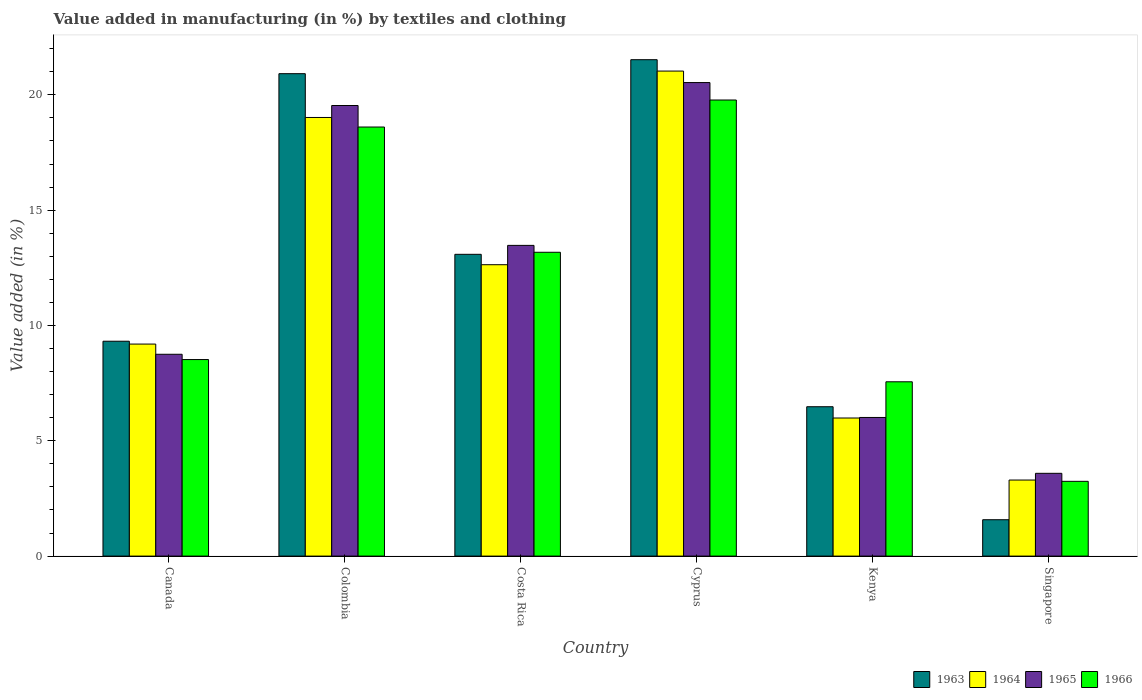How many different coloured bars are there?
Your answer should be compact. 4. Are the number of bars per tick equal to the number of legend labels?
Your response must be concise. Yes. How many bars are there on the 4th tick from the left?
Your response must be concise. 4. How many bars are there on the 4th tick from the right?
Your response must be concise. 4. What is the label of the 2nd group of bars from the left?
Provide a short and direct response. Colombia. In how many cases, is the number of bars for a given country not equal to the number of legend labels?
Your answer should be compact. 0. What is the percentage of value added in manufacturing by textiles and clothing in 1966 in Singapore?
Give a very brief answer. 3.24. Across all countries, what is the maximum percentage of value added in manufacturing by textiles and clothing in 1964?
Provide a short and direct response. 21.03. Across all countries, what is the minimum percentage of value added in manufacturing by textiles and clothing in 1965?
Offer a terse response. 3.59. In which country was the percentage of value added in manufacturing by textiles and clothing in 1963 maximum?
Provide a short and direct response. Cyprus. In which country was the percentage of value added in manufacturing by textiles and clothing in 1965 minimum?
Keep it short and to the point. Singapore. What is the total percentage of value added in manufacturing by textiles and clothing in 1964 in the graph?
Your answer should be very brief. 71.16. What is the difference between the percentage of value added in manufacturing by textiles and clothing in 1963 in Canada and that in Singapore?
Your answer should be compact. 7.74. What is the difference between the percentage of value added in manufacturing by textiles and clothing in 1965 in Costa Rica and the percentage of value added in manufacturing by textiles and clothing in 1964 in Kenya?
Make the answer very short. 7.48. What is the average percentage of value added in manufacturing by textiles and clothing in 1964 per country?
Make the answer very short. 11.86. What is the difference between the percentage of value added in manufacturing by textiles and clothing of/in 1964 and percentage of value added in manufacturing by textiles and clothing of/in 1963 in Canada?
Provide a short and direct response. -0.12. In how many countries, is the percentage of value added in manufacturing by textiles and clothing in 1964 greater than 18 %?
Offer a very short reply. 2. What is the ratio of the percentage of value added in manufacturing by textiles and clothing in 1963 in Canada to that in Singapore?
Make the answer very short. 5.91. What is the difference between the highest and the second highest percentage of value added in manufacturing by textiles and clothing in 1964?
Offer a very short reply. 6.38. What is the difference between the highest and the lowest percentage of value added in manufacturing by textiles and clothing in 1965?
Provide a succinct answer. 16.94. Is the sum of the percentage of value added in manufacturing by textiles and clothing in 1966 in Colombia and Singapore greater than the maximum percentage of value added in manufacturing by textiles and clothing in 1965 across all countries?
Keep it short and to the point. Yes. What does the 1st bar from the right in Colombia represents?
Your response must be concise. 1966. How many bars are there?
Provide a short and direct response. 24. Are all the bars in the graph horizontal?
Ensure brevity in your answer.  No. How many countries are there in the graph?
Make the answer very short. 6. Does the graph contain grids?
Make the answer very short. No. How many legend labels are there?
Your answer should be compact. 4. What is the title of the graph?
Provide a succinct answer. Value added in manufacturing (in %) by textiles and clothing. Does "2010" appear as one of the legend labels in the graph?
Provide a succinct answer. No. What is the label or title of the Y-axis?
Your response must be concise. Value added (in %). What is the Value added (in %) in 1963 in Canada?
Your answer should be compact. 9.32. What is the Value added (in %) of 1964 in Canada?
Provide a short and direct response. 9.19. What is the Value added (in %) in 1965 in Canada?
Keep it short and to the point. 8.75. What is the Value added (in %) of 1966 in Canada?
Make the answer very short. 8.52. What is the Value added (in %) in 1963 in Colombia?
Ensure brevity in your answer.  20.92. What is the Value added (in %) in 1964 in Colombia?
Provide a short and direct response. 19.02. What is the Value added (in %) of 1965 in Colombia?
Your answer should be compact. 19.54. What is the Value added (in %) of 1966 in Colombia?
Provide a succinct answer. 18.6. What is the Value added (in %) in 1963 in Costa Rica?
Your answer should be compact. 13.08. What is the Value added (in %) of 1964 in Costa Rica?
Provide a short and direct response. 12.63. What is the Value added (in %) in 1965 in Costa Rica?
Provide a succinct answer. 13.47. What is the Value added (in %) of 1966 in Costa Rica?
Your response must be concise. 13.17. What is the Value added (in %) of 1963 in Cyprus?
Give a very brief answer. 21.52. What is the Value added (in %) in 1964 in Cyprus?
Make the answer very short. 21.03. What is the Value added (in %) of 1965 in Cyprus?
Ensure brevity in your answer.  20.53. What is the Value added (in %) of 1966 in Cyprus?
Make the answer very short. 19.78. What is the Value added (in %) of 1963 in Kenya?
Give a very brief answer. 6.48. What is the Value added (in %) of 1964 in Kenya?
Your response must be concise. 5.99. What is the Value added (in %) in 1965 in Kenya?
Make the answer very short. 6.01. What is the Value added (in %) in 1966 in Kenya?
Offer a terse response. 7.56. What is the Value added (in %) in 1963 in Singapore?
Make the answer very short. 1.58. What is the Value added (in %) in 1964 in Singapore?
Your response must be concise. 3.3. What is the Value added (in %) in 1965 in Singapore?
Keep it short and to the point. 3.59. What is the Value added (in %) in 1966 in Singapore?
Offer a terse response. 3.24. Across all countries, what is the maximum Value added (in %) of 1963?
Provide a succinct answer. 21.52. Across all countries, what is the maximum Value added (in %) of 1964?
Offer a terse response. 21.03. Across all countries, what is the maximum Value added (in %) of 1965?
Your response must be concise. 20.53. Across all countries, what is the maximum Value added (in %) in 1966?
Keep it short and to the point. 19.78. Across all countries, what is the minimum Value added (in %) in 1963?
Give a very brief answer. 1.58. Across all countries, what is the minimum Value added (in %) of 1964?
Give a very brief answer. 3.3. Across all countries, what is the minimum Value added (in %) of 1965?
Your answer should be compact. 3.59. Across all countries, what is the minimum Value added (in %) in 1966?
Your answer should be very brief. 3.24. What is the total Value added (in %) in 1963 in the graph?
Your answer should be very brief. 72.9. What is the total Value added (in %) in 1964 in the graph?
Offer a very short reply. 71.16. What is the total Value added (in %) in 1965 in the graph?
Keep it short and to the point. 71.89. What is the total Value added (in %) of 1966 in the graph?
Your answer should be very brief. 70.87. What is the difference between the Value added (in %) in 1963 in Canada and that in Colombia?
Keep it short and to the point. -11.6. What is the difference between the Value added (in %) in 1964 in Canada and that in Colombia?
Give a very brief answer. -9.82. What is the difference between the Value added (in %) in 1965 in Canada and that in Colombia?
Provide a succinct answer. -10.79. What is the difference between the Value added (in %) of 1966 in Canada and that in Colombia?
Your answer should be compact. -10.08. What is the difference between the Value added (in %) of 1963 in Canada and that in Costa Rica?
Provide a short and direct response. -3.77. What is the difference between the Value added (in %) in 1964 in Canada and that in Costa Rica?
Make the answer very short. -3.44. What is the difference between the Value added (in %) of 1965 in Canada and that in Costa Rica?
Provide a succinct answer. -4.72. What is the difference between the Value added (in %) of 1966 in Canada and that in Costa Rica?
Offer a terse response. -4.65. What is the difference between the Value added (in %) of 1963 in Canada and that in Cyprus?
Give a very brief answer. -12.21. What is the difference between the Value added (in %) in 1964 in Canada and that in Cyprus?
Keep it short and to the point. -11.84. What is the difference between the Value added (in %) of 1965 in Canada and that in Cyprus?
Make the answer very short. -11.78. What is the difference between the Value added (in %) of 1966 in Canada and that in Cyprus?
Your answer should be compact. -11.25. What is the difference between the Value added (in %) in 1963 in Canada and that in Kenya?
Give a very brief answer. 2.84. What is the difference between the Value added (in %) in 1964 in Canada and that in Kenya?
Give a very brief answer. 3.21. What is the difference between the Value added (in %) of 1965 in Canada and that in Kenya?
Provide a short and direct response. 2.74. What is the difference between the Value added (in %) in 1966 in Canada and that in Kenya?
Make the answer very short. 0.96. What is the difference between the Value added (in %) in 1963 in Canada and that in Singapore?
Provide a succinct answer. 7.74. What is the difference between the Value added (in %) in 1964 in Canada and that in Singapore?
Your answer should be compact. 5.9. What is the difference between the Value added (in %) of 1965 in Canada and that in Singapore?
Ensure brevity in your answer.  5.16. What is the difference between the Value added (in %) in 1966 in Canada and that in Singapore?
Your response must be concise. 5.28. What is the difference between the Value added (in %) of 1963 in Colombia and that in Costa Rica?
Give a very brief answer. 7.83. What is the difference between the Value added (in %) in 1964 in Colombia and that in Costa Rica?
Your answer should be very brief. 6.38. What is the difference between the Value added (in %) in 1965 in Colombia and that in Costa Rica?
Offer a very short reply. 6.06. What is the difference between the Value added (in %) of 1966 in Colombia and that in Costa Rica?
Give a very brief answer. 5.43. What is the difference between the Value added (in %) of 1963 in Colombia and that in Cyprus?
Offer a terse response. -0.61. What is the difference between the Value added (in %) in 1964 in Colombia and that in Cyprus?
Keep it short and to the point. -2.01. What is the difference between the Value added (in %) in 1965 in Colombia and that in Cyprus?
Provide a short and direct response. -0.99. What is the difference between the Value added (in %) in 1966 in Colombia and that in Cyprus?
Offer a terse response. -1.17. What is the difference between the Value added (in %) of 1963 in Colombia and that in Kenya?
Make the answer very short. 14.44. What is the difference between the Value added (in %) in 1964 in Colombia and that in Kenya?
Give a very brief answer. 13.03. What is the difference between the Value added (in %) in 1965 in Colombia and that in Kenya?
Offer a very short reply. 13.53. What is the difference between the Value added (in %) in 1966 in Colombia and that in Kenya?
Give a very brief answer. 11.05. What is the difference between the Value added (in %) of 1963 in Colombia and that in Singapore?
Keep it short and to the point. 19.34. What is the difference between the Value added (in %) of 1964 in Colombia and that in Singapore?
Make the answer very short. 15.72. What is the difference between the Value added (in %) of 1965 in Colombia and that in Singapore?
Give a very brief answer. 15.95. What is the difference between the Value added (in %) in 1966 in Colombia and that in Singapore?
Your answer should be very brief. 15.36. What is the difference between the Value added (in %) of 1963 in Costa Rica and that in Cyprus?
Offer a terse response. -8.44. What is the difference between the Value added (in %) in 1964 in Costa Rica and that in Cyprus?
Provide a succinct answer. -8.4. What is the difference between the Value added (in %) in 1965 in Costa Rica and that in Cyprus?
Keep it short and to the point. -7.06. What is the difference between the Value added (in %) of 1966 in Costa Rica and that in Cyprus?
Your response must be concise. -6.6. What is the difference between the Value added (in %) of 1963 in Costa Rica and that in Kenya?
Provide a short and direct response. 6.61. What is the difference between the Value added (in %) of 1964 in Costa Rica and that in Kenya?
Offer a terse response. 6.65. What is the difference between the Value added (in %) in 1965 in Costa Rica and that in Kenya?
Keep it short and to the point. 7.46. What is the difference between the Value added (in %) in 1966 in Costa Rica and that in Kenya?
Provide a succinct answer. 5.62. What is the difference between the Value added (in %) in 1963 in Costa Rica and that in Singapore?
Provide a short and direct response. 11.51. What is the difference between the Value added (in %) in 1964 in Costa Rica and that in Singapore?
Ensure brevity in your answer.  9.34. What is the difference between the Value added (in %) of 1965 in Costa Rica and that in Singapore?
Ensure brevity in your answer.  9.88. What is the difference between the Value added (in %) of 1966 in Costa Rica and that in Singapore?
Give a very brief answer. 9.93. What is the difference between the Value added (in %) in 1963 in Cyprus and that in Kenya?
Make the answer very short. 15.05. What is the difference between the Value added (in %) in 1964 in Cyprus and that in Kenya?
Your answer should be very brief. 15.04. What is the difference between the Value added (in %) in 1965 in Cyprus and that in Kenya?
Your answer should be compact. 14.52. What is the difference between the Value added (in %) in 1966 in Cyprus and that in Kenya?
Your answer should be very brief. 12.22. What is the difference between the Value added (in %) in 1963 in Cyprus and that in Singapore?
Give a very brief answer. 19.95. What is the difference between the Value added (in %) in 1964 in Cyprus and that in Singapore?
Your response must be concise. 17.73. What is the difference between the Value added (in %) of 1965 in Cyprus and that in Singapore?
Your answer should be compact. 16.94. What is the difference between the Value added (in %) of 1966 in Cyprus and that in Singapore?
Your response must be concise. 16.53. What is the difference between the Value added (in %) in 1963 in Kenya and that in Singapore?
Offer a terse response. 4.9. What is the difference between the Value added (in %) of 1964 in Kenya and that in Singapore?
Ensure brevity in your answer.  2.69. What is the difference between the Value added (in %) in 1965 in Kenya and that in Singapore?
Provide a short and direct response. 2.42. What is the difference between the Value added (in %) in 1966 in Kenya and that in Singapore?
Provide a short and direct response. 4.32. What is the difference between the Value added (in %) of 1963 in Canada and the Value added (in %) of 1964 in Colombia?
Provide a succinct answer. -9.7. What is the difference between the Value added (in %) in 1963 in Canada and the Value added (in %) in 1965 in Colombia?
Provide a succinct answer. -10.22. What is the difference between the Value added (in %) in 1963 in Canada and the Value added (in %) in 1966 in Colombia?
Ensure brevity in your answer.  -9.29. What is the difference between the Value added (in %) of 1964 in Canada and the Value added (in %) of 1965 in Colombia?
Give a very brief answer. -10.34. What is the difference between the Value added (in %) of 1964 in Canada and the Value added (in %) of 1966 in Colombia?
Ensure brevity in your answer.  -9.41. What is the difference between the Value added (in %) of 1965 in Canada and the Value added (in %) of 1966 in Colombia?
Provide a short and direct response. -9.85. What is the difference between the Value added (in %) of 1963 in Canada and the Value added (in %) of 1964 in Costa Rica?
Offer a very short reply. -3.32. What is the difference between the Value added (in %) of 1963 in Canada and the Value added (in %) of 1965 in Costa Rica?
Your answer should be compact. -4.16. What is the difference between the Value added (in %) of 1963 in Canada and the Value added (in %) of 1966 in Costa Rica?
Your answer should be very brief. -3.86. What is the difference between the Value added (in %) in 1964 in Canada and the Value added (in %) in 1965 in Costa Rica?
Keep it short and to the point. -4.28. What is the difference between the Value added (in %) in 1964 in Canada and the Value added (in %) in 1966 in Costa Rica?
Your response must be concise. -3.98. What is the difference between the Value added (in %) in 1965 in Canada and the Value added (in %) in 1966 in Costa Rica?
Provide a succinct answer. -4.42. What is the difference between the Value added (in %) in 1963 in Canada and the Value added (in %) in 1964 in Cyprus?
Make the answer very short. -11.71. What is the difference between the Value added (in %) in 1963 in Canada and the Value added (in %) in 1965 in Cyprus?
Make the answer very short. -11.21. What is the difference between the Value added (in %) in 1963 in Canada and the Value added (in %) in 1966 in Cyprus?
Offer a terse response. -10.46. What is the difference between the Value added (in %) of 1964 in Canada and the Value added (in %) of 1965 in Cyprus?
Your response must be concise. -11.34. What is the difference between the Value added (in %) in 1964 in Canada and the Value added (in %) in 1966 in Cyprus?
Your answer should be compact. -10.58. What is the difference between the Value added (in %) in 1965 in Canada and the Value added (in %) in 1966 in Cyprus?
Your response must be concise. -11.02. What is the difference between the Value added (in %) of 1963 in Canada and the Value added (in %) of 1964 in Kenya?
Give a very brief answer. 3.33. What is the difference between the Value added (in %) of 1963 in Canada and the Value added (in %) of 1965 in Kenya?
Provide a succinct answer. 3.31. What is the difference between the Value added (in %) in 1963 in Canada and the Value added (in %) in 1966 in Kenya?
Your response must be concise. 1.76. What is the difference between the Value added (in %) in 1964 in Canada and the Value added (in %) in 1965 in Kenya?
Provide a succinct answer. 3.18. What is the difference between the Value added (in %) of 1964 in Canada and the Value added (in %) of 1966 in Kenya?
Ensure brevity in your answer.  1.64. What is the difference between the Value added (in %) of 1965 in Canada and the Value added (in %) of 1966 in Kenya?
Keep it short and to the point. 1.19. What is the difference between the Value added (in %) in 1963 in Canada and the Value added (in %) in 1964 in Singapore?
Your response must be concise. 6.02. What is the difference between the Value added (in %) of 1963 in Canada and the Value added (in %) of 1965 in Singapore?
Keep it short and to the point. 5.73. What is the difference between the Value added (in %) of 1963 in Canada and the Value added (in %) of 1966 in Singapore?
Your answer should be compact. 6.08. What is the difference between the Value added (in %) in 1964 in Canada and the Value added (in %) in 1965 in Singapore?
Ensure brevity in your answer.  5.6. What is the difference between the Value added (in %) in 1964 in Canada and the Value added (in %) in 1966 in Singapore?
Provide a short and direct response. 5.95. What is the difference between the Value added (in %) in 1965 in Canada and the Value added (in %) in 1966 in Singapore?
Keep it short and to the point. 5.51. What is the difference between the Value added (in %) of 1963 in Colombia and the Value added (in %) of 1964 in Costa Rica?
Offer a very short reply. 8.28. What is the difference between the Value added (in %) of 1963 in Colombia and the Value added (in %) of 1965 in Costa Rica?
Provide a succinct answer. 7.44. What is the difference between the Value added (in %) of 1963 in Colombia and the Value added (in %) of 1966 in Costa Rica?
Give a very brief answer. 7.74. What is the difference between the Value added (in %) of 1964 in Colombia and the Value added (in %) of 1965 in Costa Rica?
Ensure brevity in your answer.  5.55. What is the difference between the Value added (in %) in 1964 in Colombia and the Value added (in %) in 1966 in Costa Rica?
Make the answer very short. 5.84. What is the difference between the Value added (in %) of 1965 in Colombia and the Value added (in %) of 1966 in Costa Rica?
Make the answer very short. 6.36. What is the difference between the Value added (in %) in 1963 in Colombia and the Value added (in %) in 1964 in Cyprus?
Give a very brief answer. -0.11. What is the difference between the Value added (in %) in 1963 in Colombia and the Value added (in %) in 1965 in Cyprus?
Offer a very short reply. 0.39. What is the difference between the Value added (in %) of 1963 in Colombia and the Value added (in %) of 1966 in Cyprus?
Provide a short and direct response. 1.14. What is the difference between the Value added (in %) of 1964 in Colombia and the Value added (in %) of 1965 in Cyprus?
Give a very brief answer. -1.51. What is the difference between the Value added (in %) in 1964 in Colombia and the Value added (in %) in 1966 in Cyprus?
Give a very brief answer. -0.76. What is the difference between the Value added (in %) in 1965 in Colombia and the Value added (in %) in 1966 in Cyprus?
Provide a short and direct response. -0.24. What is the difference between the Value added (in %) of 1963 in Colombia and the Value added (in %) of 1964 in Kenya?
Ensure brevity in your answer.  14.93. What is the difference between the Value added (in %) in 1963 in Colombia and the Value added (in %) in 1965 in Kenya?
Provide a short and direct response. 14.91. What is the difference between the Value added (in %) of 1963 in Colombia and the Value added (in %) of 1966 in Kenya?
Ensure brevity in your answer.  13.36. What is the difference between the Value added (in %) in 1964 in Colombia and the Value added (in %) in 1965 in Kenya?
Your answer should be compact. 13.01. What is the difference between the Value added (in %) in 1964 in Colombia and the Value added (in %) in 1966 in Kenya?
Offer a terse response. 11.46. What is the difference between the Value added (in %) in 1965 in Colombia and the Value added (in %) in 1966 in Kenya?
Provide a short and direct response. 11.98. What is the difference between the Value added (in %) of 1963 in Colombia and the Value added (in %) of 1964 in Singapore?
Your answer should be compact. 17.62. What is the difference between the Value added (in %) in 1963 in Colombia and the Value added (in %) in 1965 in Singapore?
Your response must be concise. 17.33. What is the difference between the Value added (in %) of 1963 in Colombia and the Value added (in %) of 1966 in Singapore?
Offer a very short reply. 17.68. What is the difference between the Value added (in %) in 1964 in Colombia and the Value added (in %) in 1965 in Singapore?
Keep it short and to the point. 15.43. What is the difference between the Value added (in %) of 1964 in Colombia and the Value added (in %) of 1966 in Singapore?
Provide a succinct answer. 15.78. What is the difference between the Value added (in %) of 1965 in Colombia and the Value added (in %) of 1966 in Singapore?
Your answer should be compact. 16.3. What is the difference between the Value added (in %) of 1963 in Costa Rica and the Value added (in %) of 1964 in Cyprus?
Ensure brevity in your answer.  -7.95. What is the difference between the Value added (in %) of 1963 in Costa Rica and the Value added (in %) of 1965 in Cyprus?
Provide a short and direct response. -7.45. What is the difference between the Value added (in %) of 1963 in Costa Rica and the Value added (in %) of 1966 in Cyprus?
Your answer should be compact. -6.69. What is the difference between the Value added (in %) in 1964 in Costa Rica and the Value added (in %) in 1965 in Cyprus?
Offer a very short reply. -7.9. What is the difference between the Value added (in %) in 1964 in Costa Rica and the Value added (in %) in 1966 in Cyprus?
Your answer should be compact. -7.14. What is the difference between the Value added (in %) in 1965 in Costa Rica and the Value added (in %) in 1966 in Cyprus?
Make the answer very short. -6.3. What is the difference between the Value added (in %) of 1963 in Costa Rica and the Value added (in %) of 1964 in Kenya?
Your answer should be very brief. 7.1. What is the difference between the Value added (in %) in 1963 in Costa Rica and the Value added (in %) in 1965 in Kenya?
Provide a short and direct response. 7.07. What is the difference between the Value added (in %) in 1963 in Costa Rica and the Value added (in %) in 1966 in Kenya?
Provide a short and direct response. 5.53. What is the difference between the Value added (in %) of 1964 in Costa Rica and the Value added (in %) of 1965 in Kenya?
Provide a succinct answer. 6.62. What is the difference between the Value added (in %) in 1964 in Costa Rica and the Value added (in %) in 1966 in Kenya?
Your answer should be very brief. 5.08. What is the difference between the Value added (in %) in 1965 in Costa Rica and the Value added (in %) in 1966 in Kenya?
Give a very brief answer. 5.91. What is the difference between the Value added (in %) of 1963 in Costa Rica and the Value added (in %) of 1964 in Singapore?
Provide a succinct answer. 9.79. What is the difference between the Value added (in %) in 1963 in Costa Rica and the Value added (in %) in 1965 in Singapore?
Make the answer very short. 9.5. What is the difference between the Value added (in %) in 1963 in Costa Rica and the Value added (in %) in 1966 in Singapore?
Give a very brief answer. 9.84. What is the difference between the Value added (in %) of 1964 in Costa Rica and the Value added (in %) of 1965 in Singapore?
Keep it short and to the point. 9.04. What is the difference between the Value added (in %) in 1964 in Costa Rica and the Value added (in %) in 1966 in Singapore?
Your answer should be very brief. 9.39. What is the difference between the Value added (in %) in 1965 in Costa Rica and the Value added (in %) in 1966 in Singapore?
Your answer should be very brief. 10.23. What is the difference between the Value added (in %) of 1963 in Cyprus and the Value added (in %) of 1964 in Kenya?
Provide a short and direct response. 15.54. What is the difference between the Value added (in %) in 1963 in Cyprus and the Value added (in %) in 1965 in Kenya?
Your answer should be compact. 15.51. What is the difference between the Value added (in %) of 1963 in Cyprus and the Value added (in %) of 1966 in Kenya?
Give a very brief answer. 13.97. What is the difference between the Value added (in %) of 1964 in Cyprus and the Value added (in %) of 1965 in Kenya?
Ensure brevity in your answer.  15.02. What is the difference between the Value added (in %) of 1964 in Cyprus and the Value added (in %) of 1966 in Kenya?
Keep it short and to the point. 13.47. What is the difference between the Value added (in %) of 1965 in Cyprus and the Value added (in %) of 1966 in Kenya?
Provide a succinct answer. 12.97. What is the difference between the Value added (in %) of 1963 in Cyprus and the Value added (in %) of 1964 in Singapore?
Your response must be concise. 18.23. What is the difference between the Value added (in %) of 1963 in Cyprus and the Value added (in %) of 1965 in Singapore?
Make the answer very short. 17.93. What is the difference between the Value added (in %) of 1963 in Cyprus and the Value added (in %) of 1966 in Singapore?
Your answer should be compact. 18.28. What is the difference between the Value added (in %) in 1964 in Cyprus and the Value added (in %) in 1965 in Singapore?
Your answer should be compact. 17.44. What is the difference between the Value added (in %) in 1964 in Cyprus and the Value added (in %) in 1966 in Singapore?
Your answer should be compact. 17.79. What is the difference between the Value added (in %) in 1965 in Cyprus and the Value added (in %) in 1966 in Singapore?
Offer a terse response. 17.29. What is the difference between the Value added (in %) of 1963 in Kenya and the Value added (in %) of 1964 in Singapore?
Offer a very short reply. 3.18. What is the difference between the Value added (in %) of 1963 in Kenya and the Value added (in %) of 1965 in Singapore?
Provide a short and direct response. 2.89. What is the difference between the Value added (in %) in 1963 in Kenya and the Value added (in %) in 1966 in Singapore?
Your response must be concise. 3.24. What is the difference between the Value added (in %) in 1964 in Kenya and the Value added (in %) in 1965 in Singapore?
Offer a very short reply. 2.4. What is the difference between the Value added (in %) in 1964 in Kenya and the Value added (in %) in 1966 in Singapore?
Your answer should be very brief. 2.75. What is the difference between the Value added (in %) of 1965 in Kenya and the Value added (in %) of 1966 in Singapore?
Offer a terse response. 2.77. What is the average Value added (in %) in 1963 per country?
Make the answer very short. 12.15. What is the average Value added (in %) in 1964 per country?
Provide a succinct answer. 11.86. What is the average Value added (in %) in 1965 per country?
Your answer should be compact. 11.98. What is the average Value added (in %) in 1966 per country?
Provide a succinct answer. 11.81. What is the difference between the Value added (in %) of 1963 and Value added (in %) of 1964 in Canada?
Your answer should be compact. 0.12. What is the difference between the Value added (in %) of 1963 and Value added (in %) of 1965 in Canada?
Keep it short and to the point. 0.57. What is the difference between the Value added (in %) of 1963 and Value added (in %) of 1966 in Canada?
Give a very brief answer. 0.8. What is the difference between the Value added (in %) of 1964 and Value added (in %) of 1965 in Canada?
Provide a short and direct response. 0.44. What is the difference between the Value added (in %) in 1964 and Value added (in %) in 1966 in Canada?
Your answer should be very brief. 0.67. What is the difference between the Value added (in %) of 1965 and Value added (in %) of 1966 in Canada?
Keep it short and to the point. 0.23. What is the difference between the Value added (in %) of 1963 and Value added (in %) of 1964 in Colombia?
Your response must be concise. 1.9. What is the difference between the Value added (in %) in 1963 and Value added (in %) in 1965 in Colombia?
Offer a very short reply. 1.38. What is the difference between the Value added (in %) of 1963 and Value added (in %) of 1966 in Colombia?
Make the answer very short. 2.31. What is the difference between the Value added (in %) in 1964 and Value added (in %) in 1965 in Colombia?
Offer a very short reply. -0.52. What is the difference between the Value added (in %) in 1964 and Value added (in %) in 1966 in Colombia?
Make the answer very short. 0.41. What is the difference between the Value added (in %) in 1965 and Value added (in %) in 1966 in Colombia?
Make the answer very short. 0.93. What is the difference between the Value added (in %) in 1963 and Value added (in %) in 1964 in Costa Rica?
Make the answer very short. 0.45. What is the difference between the Value added (in %) in 1963 and Value added (in %) in 1965 in Costa Rica?
Give a very brief answer. -0.39. What is the difference between the Value added (in %) in 1963 and Value added (in %) in 1966 in Costa Rica?
Provide a short and direct response. -0.09. What is the difference between the Value added (in %) of 1964 and Value added (in %) of 1965 in Costa Rica?
Offer a very short reply. -0.84. What is the difference between the Value added (in %) of 1964 and Value added (in %) of 1966 in Costa Rica?
Provide a short and direct response. -0.54. What is the difference between the Value added (in %) in 1965 and Value added (in %) in 1966 in Costa Rica?
Give a very brief answer. 0.3. What is the difference between the Value added (in %) of 1963 and Value added (in %) of 1964 in Cyprus?
Give a very brief answer. 0.49. What is the difference between the Value added (in %) in 1963 and Value added (in %) in 1966 in Cyprus?
Keep it short and to the point. 1.75. What is the difference between the Value added (in %) of 1964 and Value added (in %) of 1965 in Cyprus?
Your answer should be compact. 0.5. What is the difference between the Value added (in %) in 1964 and Value added (in %) in 1966 in Cyprus?
Your answer should be very brief. 1.25. What is the difference between the Value added (in %) of 1965 and Value added (in %) of 1966 in Cyprus?
Offer a terse response. 0.76. What is the difference between the Value added (in %) of 1963 and Value added (in %) of 1964 in Kenya?
Provide a succinct answer. 0.49. What is the difference between the Value added (in %) of 1963 and Value added (in %) of 1965 in Kenya?
Provide a short and direct response. 0.47. What is the difference between the Value added (in %) in 1963 and Value added (in %) in 1966 in Kenya?
Your answer should be compact. -1.08. What is the difference between the Value added (in %) of 1964 and Value added (in %) of 1965 in Kenya?
Ensure brevity in your answer.  -0.02. What is the difference between the Value added (in %) of 1964 and Value added (in %) of 1966 in Kenya?
Your response must be concise. -1.57. What is the difference between the Value added (in %) of 1965 and Value added (in %) of 1966 in Kenya?
Ensure brevity in your answer.  -1.55. What is the difference between the Value added (in %) of 1963 and Value added (in %) of 1964 in Singapore?
Keep it short and to the point. -1.72. What is the difference between the Value added (in %) in 1963 and Value added (in %) in 1965 in Singapore?
Your answer should be compact. -2.01. What is the difference between the Value added (in %) in 1963 and Value added (in %) in 1966 in Singapore?
Provide a short and direct response. -1.66. What is the difference between the Value added (in %) of 1964 and Value added (in %) of 1965 in Singapore?
Make the answer very short. -0.29. What is the difference between the Value added (in %) in 1964 and Value added (in %) in 1966 in Singapore?
Keep it short and to the point. 0.06. What is the difference between the Value added (in %) in 1965 and Value added (in %) in 1966 in Singapore?
Offer a terse response. 0.35. What is the ratio of the Value added (in %) of 1963 in Canada to that in Colombia?
Ensure brevity in your answer.  0.45. What is the ratio of the Value added (in %) of 1964 in Canada to that in Colombia?
Provide a succinct answer. 0.48. What is the ratio of the Value added (in %) of 1965 in Canada to that in Colombia?
Offer a terse response. 0.45. What is the ratio of the Value added (in %) of 1966 in Canada to that in Colombia?
Make the answer very short. 0.46. What is the ratio of the Value added (in %) of 1963 in Canada to that in Costa Rica?
Keep it short and to the point. 0.71. What is the ratio of the Value added (in %) in 1964 in Canada to that in Costa Rica?
Give a very brief answer. 0.73. What is the ratio of the Value added (in %) in 1965 in Canada to that in Costa Rica?
Make the answer very short. 0.65. What is the ratio of the Value added (in %) of 1966 in Canada to that in Costa Rica?
Your answer should be very brief. 0.65. What is the ratio of the Value added (in %) of 1963 in Canada to that in Cyprus?
Ensure brevity in your answer.  0.43. What is the ratio of the Value added (in %) of 1964 in Canada to that in Cyprus?
Make the answer very short. 0.44. What is the ratio of the Value added (in %) in 1965 in Canada to that in Cyprus?
Your answer should be compact. 0.43. What is the ratio of the Value added (in %) of 1966 in Canada to that in Cyprus?
Ensure brevity in your answer.  0.43. What is the ratio of the Value added (in %) in 1963 in Canada to that in Kenya?
Make the answer very short. 1.44. What is the ratio of the Value added (in %) of 1964 in Canada to that in Kenya?
Your answer should be very brief. 1.54. What is the ratio of the Value added (in %) in 1965 in Canada to that in Kenya?
Provide a short and direct response. 1.46. What is the ratio of the Value added (in %) in 1966 in Canada to that in Kenya?
Make the answer very short. 1.13. What is the ratio of the Value added (in %) of 1963 in Canada to that in Singapore?
Make the answer very short. 5.91. What is the ratio of the Value added (in %) of 1964 in Canada to that in Singapore?
Offer a terse response. 2.79. What is the ratio of the Value added (in %) of 1965 in Canada to that in Singapore?
Provide a succinct answer. 2.44. What is the ratio of the Value added (in %) of 1966 in Canada to that in Singapore?
Offer a terse response. 2.63. What is the ratio of the Value added (in %) of 1963 in Colombia to that in Costa Rica?
Provide a succinct answer. 1.6. What is the ratio of the Value added (in %) of 1964 in Colombia to that in Costa Rica?
Offer a very short reply. 1.51. What is the ratio of the Value added (in %) of 1965 in Colombia to that in Costa Rica?
Provide a short and direct response. 1.45. What is the ratio of the Value added (in %) of 1966 in Colombia to that in Costa Rica?
Keep it short and to the point. 1.41. What is the ratio of the Value added (in %) in 1963 in Colombia to that in Cyprus?
Offer a terse response. 0.97. What is the ratio of the Value added (in %) in 1964 in Colombia to that in Cyprus?
Provide a short and direct response. 0.9. What is the ratio of the Value added (in %) in 1965 in Colombia to that in Cyprus?
Your answer should be very brief. 0.95. What is the ratio of the Value added (in %) of 1966 in Colombia to that in Cyprus?
Ensure brevity in your answer.  0.94. What is the ratio of the Value added (in %) in 1963 in Colombia to that in Kenya?
Your response must be concise. 3.23. What is the ratio of the Value added (in %) in 1964 in Colombia to that in Kenya?
Ensure brevity in your answer.  3.18. What is the ratio of the Value added (in %) of 1965 in Colombia to that in Kenya?
Give a very brief answer. 3.25. What is the ratio of the Value added (in %) in 1966 in Colombia to that in Kenya?
Make the answer very short. 2.46. What is the ratio of the Value added (in %) of 1963 in Colombia to that in Singapore?
Keep it short and to the point. 13.26. What is the ratio of the Value added (in %) in 1964 in Colombia to that in Singapore?
Your response must be concise. 5.77. What is the ratio of the Value added (in %) in 1965 in Colombia to that in Singapore?
Provide a succinct answer. 5.44. What is the ratio of the Value added (in %) in 1966 in Colombia to that in Singapore?
Offer a very short reply. 5.74. What is the ratio of the Value added (in %) of 1963 in Costa Rica to that in Cyprus?
Provide a succinct answer. 0.61. What is the ratio of the Value added (in %) of 1964 in Costa Rica to that in Cyprus?
Give a very brief answer. 0.6. What is the ratio of the Value added (in %) of 1965 in Costa Rica to that in Cyprus?
Your answer should be compact. 0.66. What is the ratio of the Value added (in %) in 1966 in Costa Rica to that in Cyprus?
Give a very brief answer. 0.67. What is the ratio of the Value added (in %) in 1963 in Costa Rica to that in Kenya?
Give a very brief answer. 2.02. What is the ratio of the Value added (in %) of 1964 in Costa Rica to that in Kenya?
Your answer should be compact. 2.11. What is the ratio of the Value added (in %) in 1965 in Costa Rica to that in Kenya?
Your answer should be compact. 2.24. What is the ratio of the Value added (in %) in 1966 in Costa Rica to that in Kenya?
Give a very brief answer. 1.74. What is the ratio of the Value added (in %) of 1963 in Costa Rica to that in Singapore?
Your response must be concise. 8.3. What is the ratio of the Value added (in %) in 1964 in Costa Rica to that in Singapore?
Give a very brief answer. 3.83. What is the ratio of the Value added (in %) in 1965 in Costa Rica to that in Singapore?
Your answer should be compact. 3.75. What is the ratio of the Value added (in %) in 1966 in Costa Rica to that in Singapore?
Offer a terse response. 4.06. What is the ratio of the Value added (in %) in 1963 in Cyprus to that in Kenya?
Keep it short and to the point. 3.32. What is the ratio of the Value added (in %) in 1964 in Cyprus to that in Kenya?
Your answer should be compact. 3.51. What is the ratio of the Value added (in %) of 1965 in Cyprus to that in Kenya?
Your response must be concise. 3.42. What is the ratio of the Value added (in %) of 1966 in Cyprus to that in Kenya?
Offer a very short reply. 2.62. What is the ratio of the Value added (in %) of 1963 in Cyprus to that in Singapore?
Offer a very short reply. 13.65. What is the ratio of the Value added (in %) of 1964 in Cyprus to that in Singapore?
Provide a short and direct response. 6.38. What is the ratio of the Value added (in %) in 1965 in Cyprus to that in Singapore?
Ensure brevity in your answer.  5.72. What is the ratio of the Value added (in %) of 1966 in Cyprus to that in Singapore?
Give a very brief answer. 6.1. What is the ratio of the Value added (in %) in 1963 in Kenya to that in Singapore?
Give a very brief answer. 4.11. What is the ratio of the Value added (in %) of 1964 in Kenya to that in Singapore?
Provide a short and direct response. 1.82. What is the ratio of the Value added (in %) in 1965 in Kenya to that in Singapore?
Your answer should be very brief. 1.67. What is the ratio of the Value added (in %) in 1966 in Kenya to that in Singapore?
Your response must be concise. 2.33. What is the difference between the highest and the second highest Value added (in %) in 1963?
Your answer should be very brief. 0.61. What is the difference between the highest and the second highest Value added (in %) in 1964?
Provide a short and direct response. 2.01. What is the difference between the highest and the second highest Value added (in %) in 1966?
Offer a terse response. 1.17. What is the difference between the highest and the lowest Value added (in %) of 1963?
Your answer should be compact. 19.95. What is the difference between the highest and the lowest Value added (in %) in 1964?
Keep it short and to the point. 17.73. What is the difference between the highest and the lowest Value added (in %) in 1965?
Your response must be concise. 16.94. What is the difference between the highest and the lowest Value added (in %) in 1966?
Make the answer very short. 16.53. 